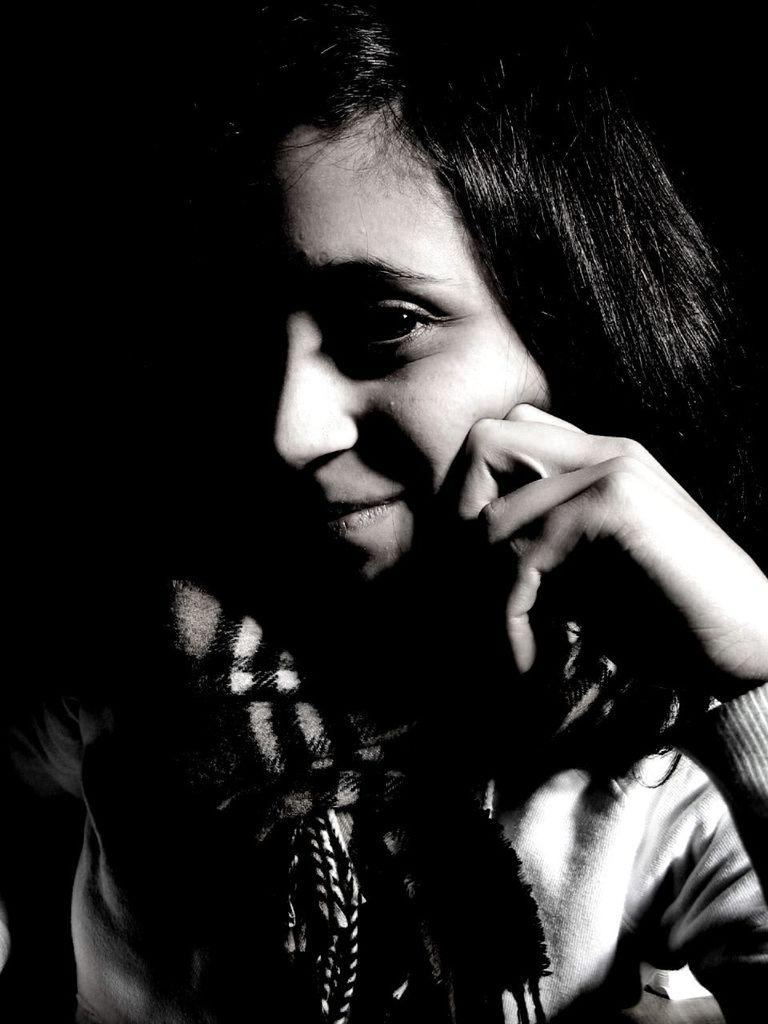What is the color scheme of the image? The image is black and white. Can you describe the person in the image? There is a woman in the image. What is the woman wearing around her neck? The woman is wearing a scarf. Are there any volcanoes visible in the image? No, there are no volcanoes present in the image. What type of bells can be heard ringing in the image? There are no bells or sounds mentioned in the image, as it is a still photograph. 